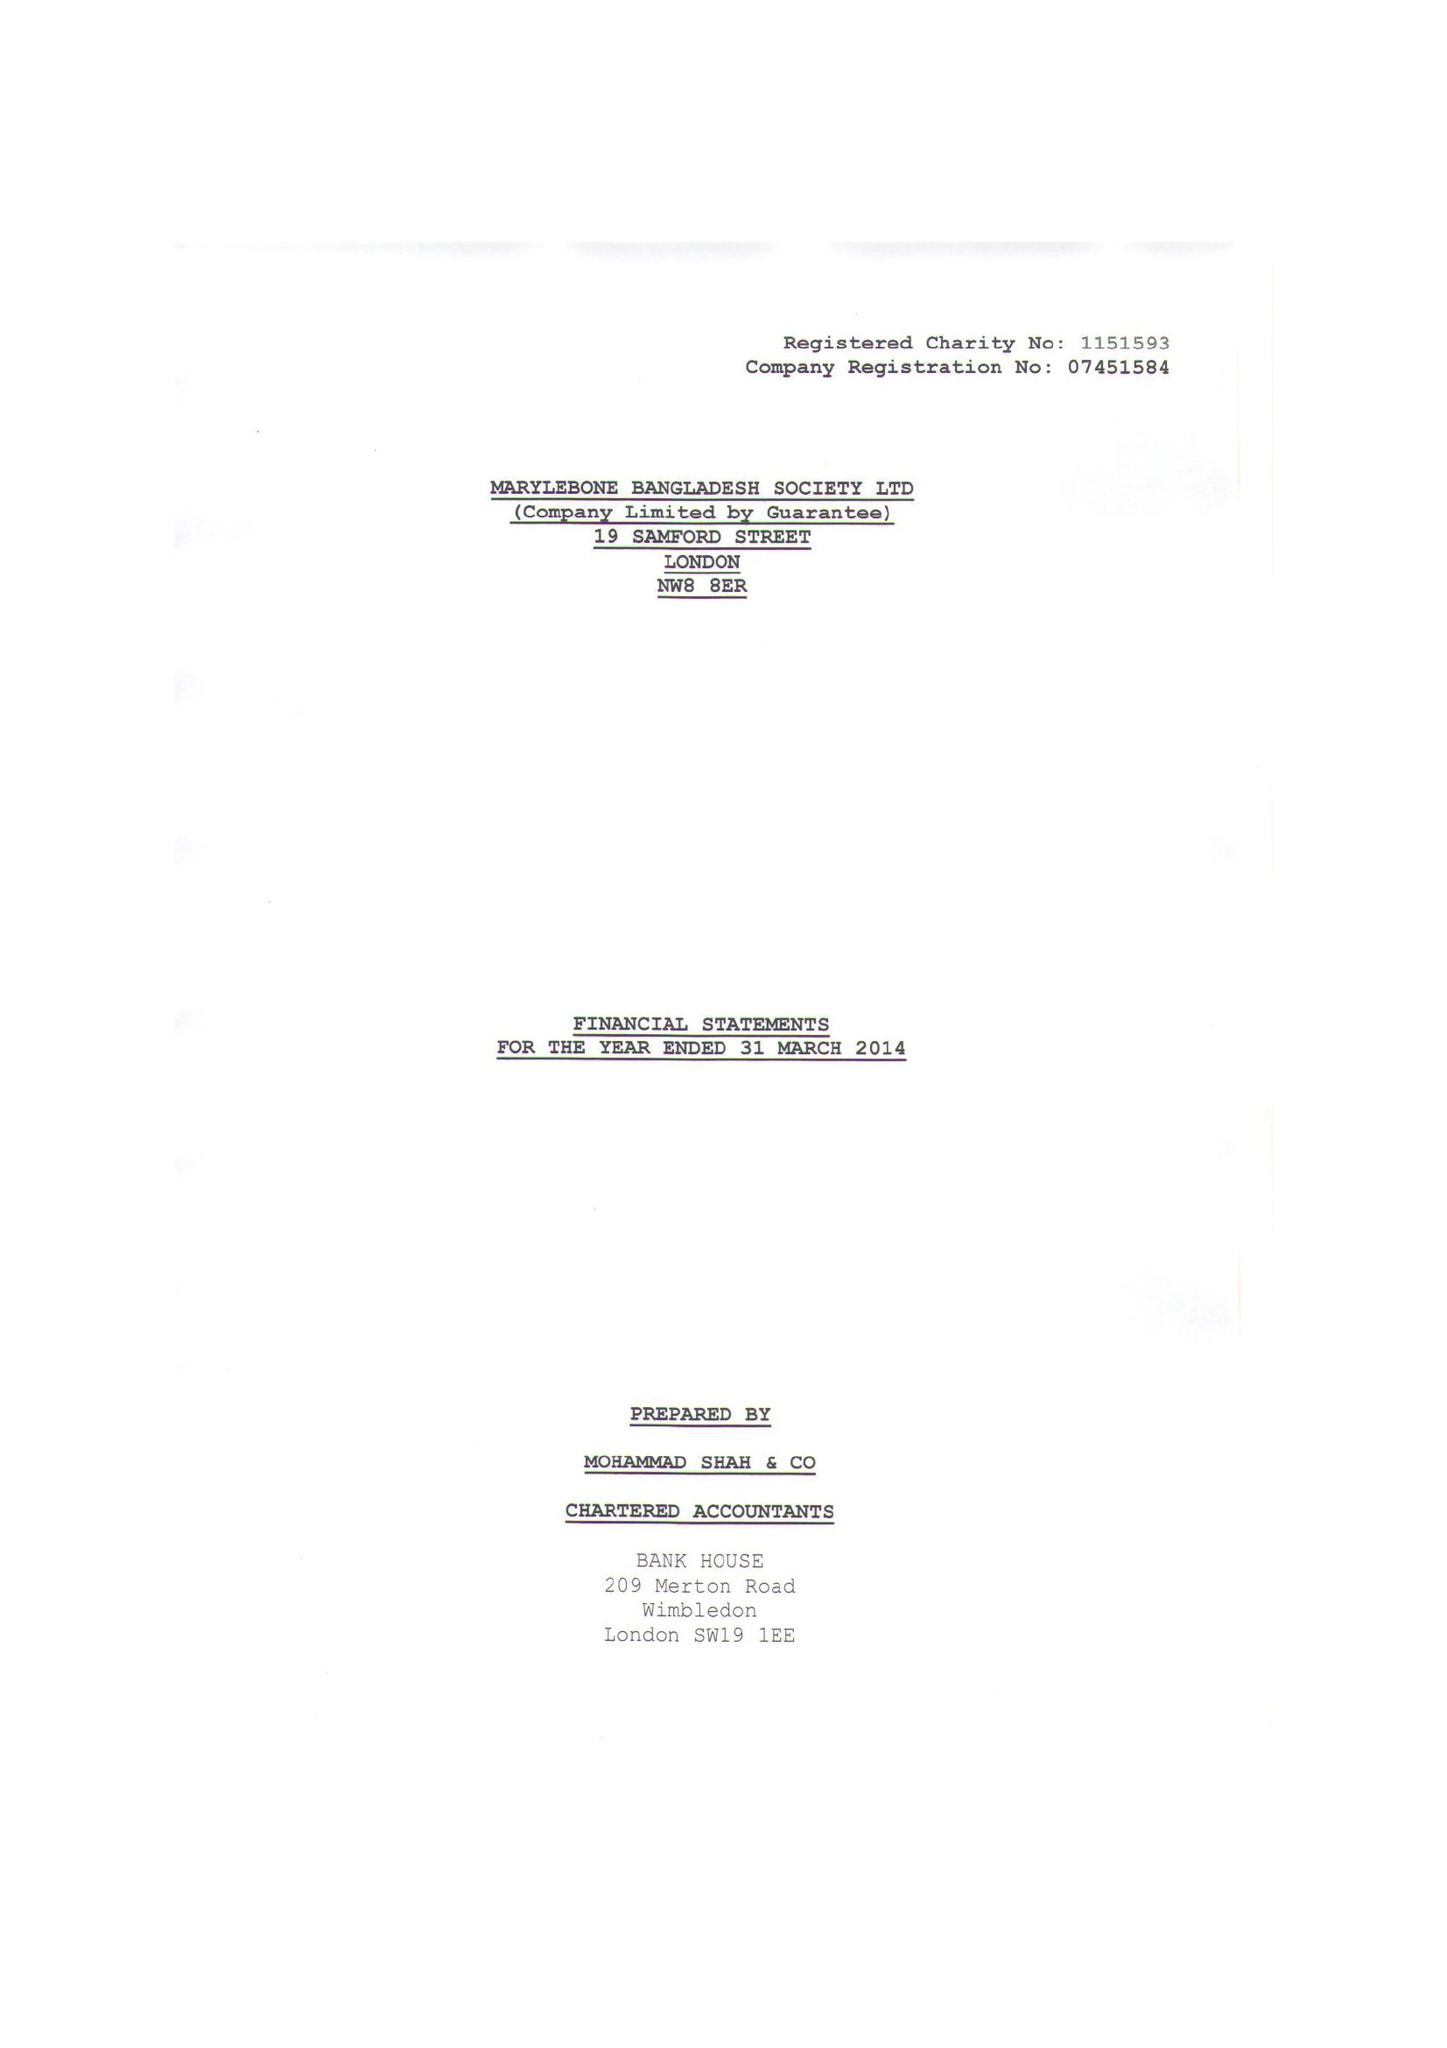What is the value for the address__post_town?
Answer the question using a single word or phrase. LONDON 